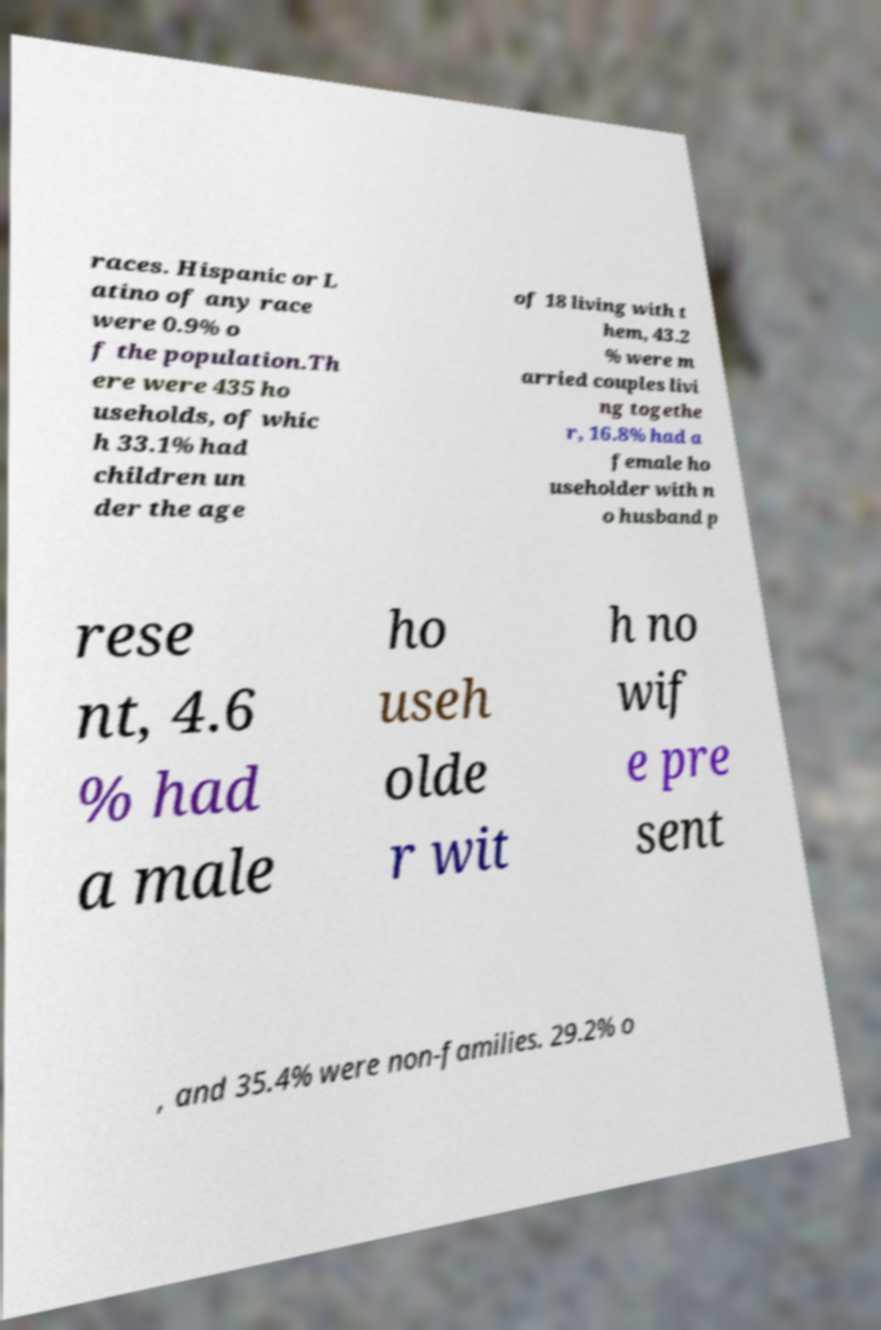For documentation purposes, I need the text within this image transcribed. Could you provide that? races. Hispanic or L atino of any race were 0.9% o f the population.Th ere were 435 ho useholds, of whic h 33.1% had children un der the age of 18 living with t hem, 43.2 % were m arried couples livi ng togethe r, 16.8% had a female ho useholder with n o husband p rese nt, 4.6 % had a male ho useh olde r wit h no wif e pre sent , and 35.4% were non-families. 29.2% o 